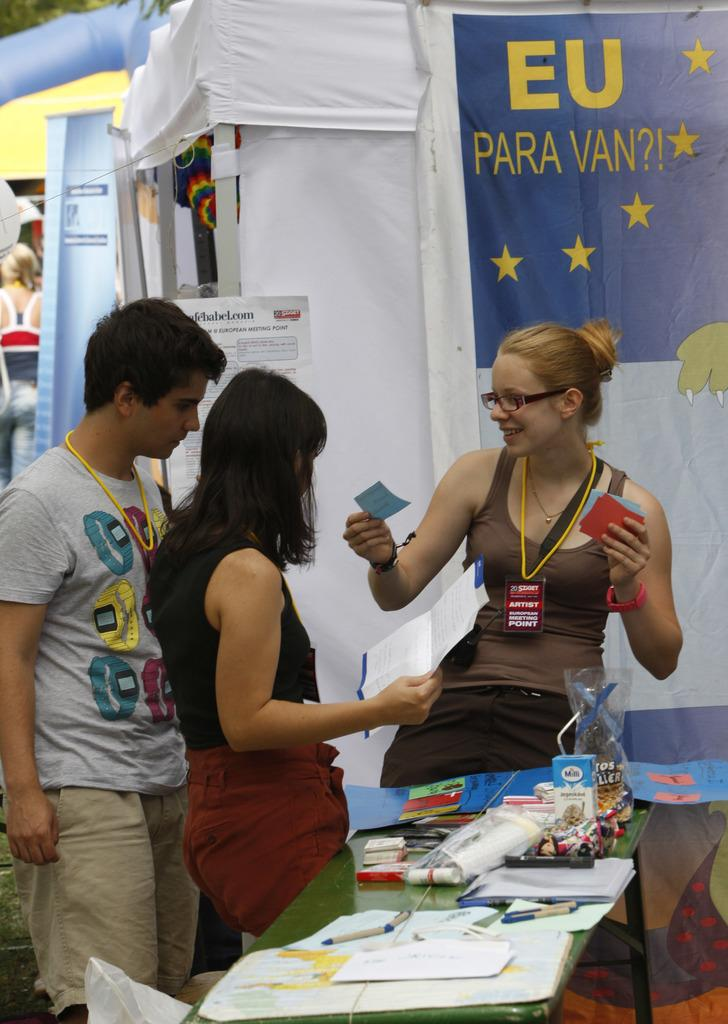<image>
Provide a brief description of the given image. The artist can be identified by the badge hanging around her neck. 